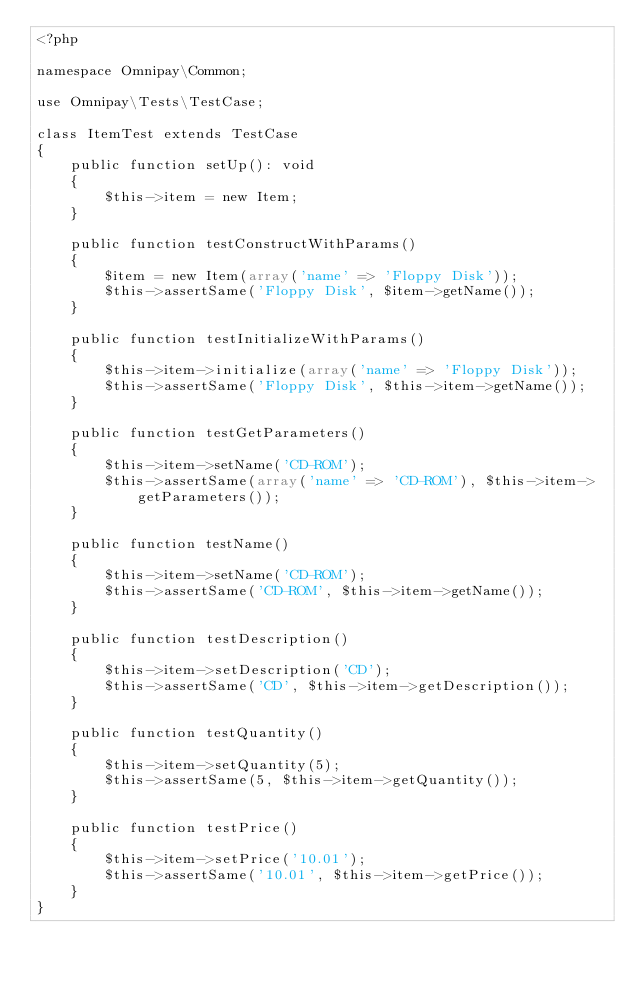<code> <loc_0><loc_0><loc_500><loc_500><_PHP_><?php

namespace Omnipay\Common;

use Omnipay\Tests\TestCase;

class ItemTest extends TestCase
{
    public function setUp(): void
    {
        $this->item = new Item;
    }

    public function testConstructWithParams()
    {
        $item = new Item(array('name' => 'Floppy Disk'));
        $this->assertSame('Floppy Disk', $item->getName());
    }

    public function testInitializeWithParams()
    {
        $this->item->initialize(array('name' => 'Floppy Disk'));
        $this->assertSame('Floppy Disk', $this->item->getName());
    }

    public function testGetParameters()
    {
        $this->item->setName('CD-ROM');
        $this->assertSame(array('name' => 'CD-ROM'), $this->item->getParameters());
    }

    public function testName()
    {
        $this->item->setName('CD-ROM');
        $this->assertSame('CD-ROM', $this->item->getName());
    }

    public function testDescription()
    {
        $this->item->setDescription('CD');
        $this->assertSame('CD', $this->item->getDescription());
    }

    public function testQuantity()
    {
        $this->item->setQuantity(5);
        $this->assertSame(5, $this->item->getQuantity());
    }

    public function testPrice()
    {
        $this->item->setPrice('10.01');
        $this->assertSame('10.01', $this->item->getPrice());
    }
}
</code> 